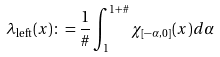<formula> <loc_0><loc_0><loc_500><loc_500>\lambda _ { \text {left} } ( x ) \colon = \frac { 1 } { \# } \int _ { 1 } ^ { 1 + \# } \chi _ { [ - \alpha , 0 ] } ( x ) d \alpha</formula> 